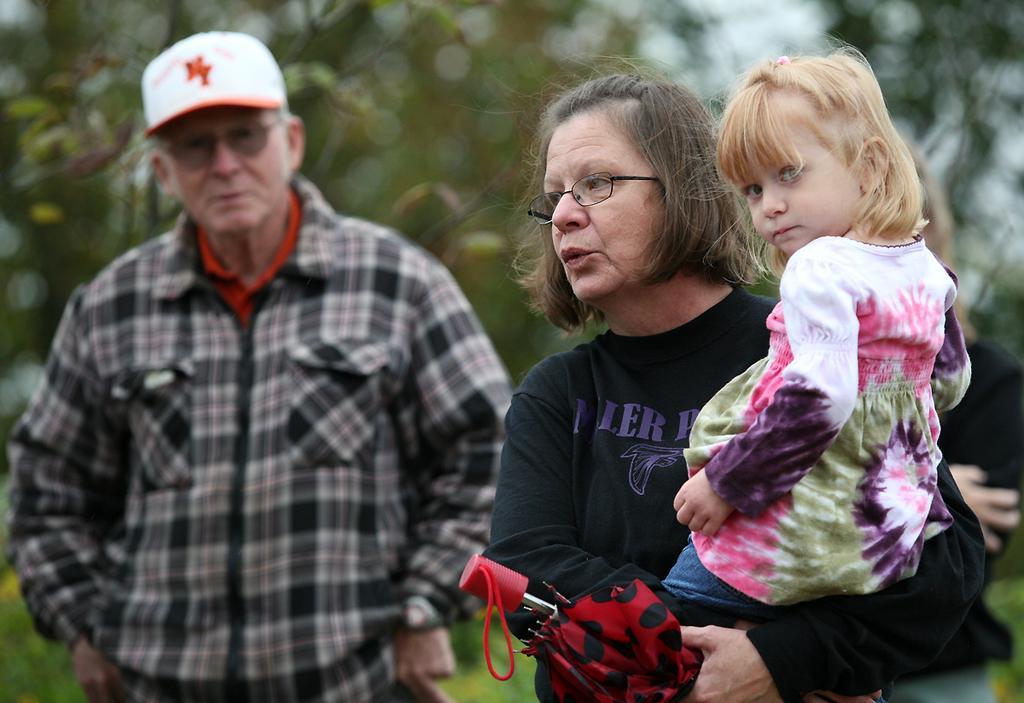Please provide a concise description of this image. In this picture there is a woman standing and holding the kid and holding the umbrella. At the back there is a man standing and there are trees. At the bottom there is grass. 